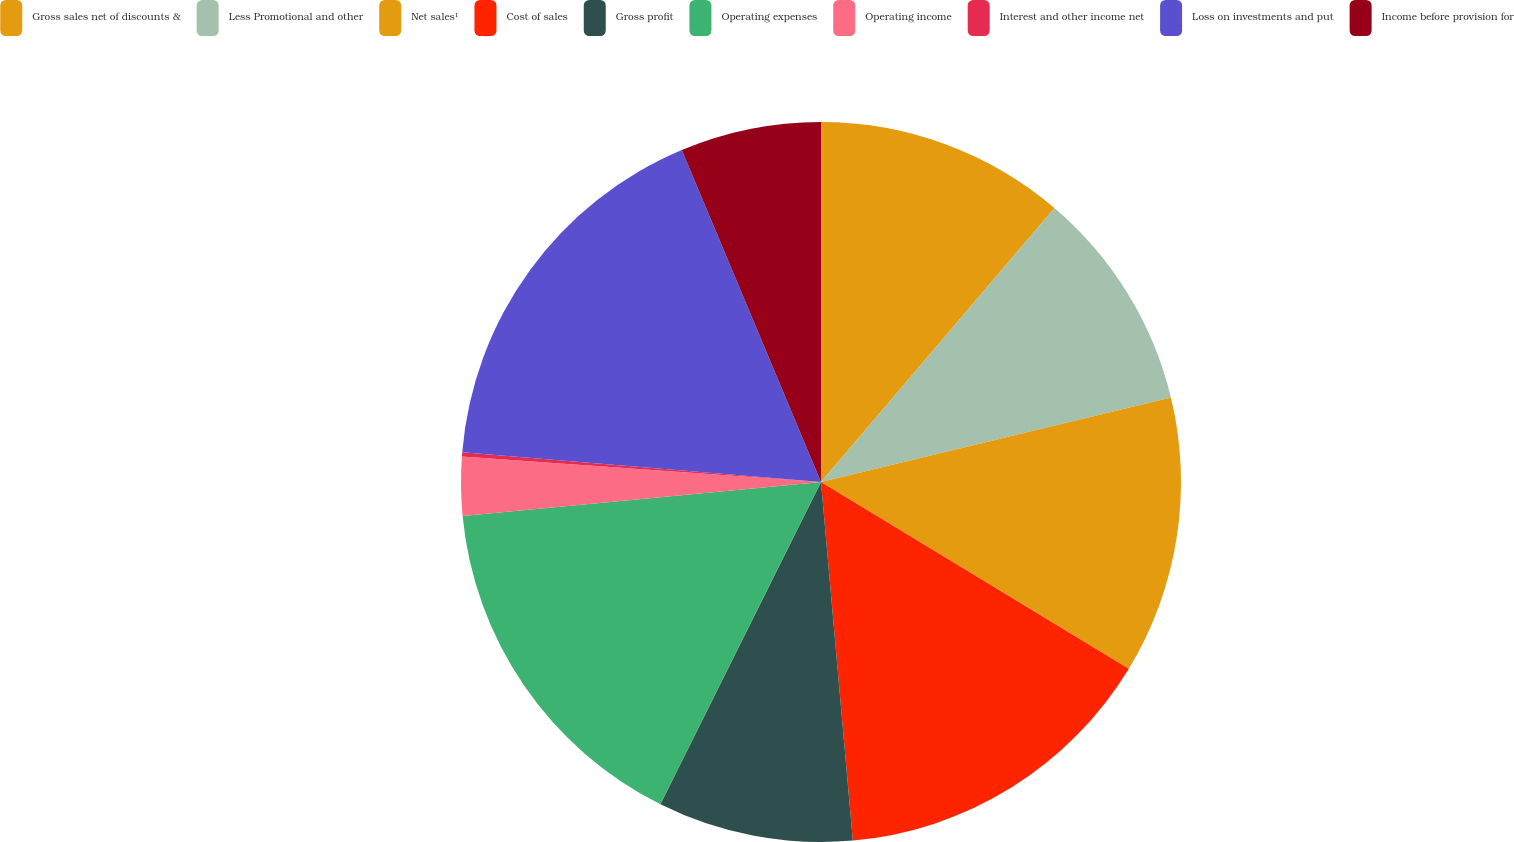<chart> <loc_0><loc_0><loc_500><loc_500><pie_chart><fcel>Gross sales net of discounts &<fcel>Less Promotional and other<fcel>Net sales¹<fcel>Cost of sales<fcel>Gross profit<fcel>Operating expenses<fcel>Operating income<fcel>Interest and other income net<fcel>Loss on investments and put<fcel>Income before provision for<nl><fcel>11.23%<fcel>10.0%<fcel>12.45%<fcel>14.91%<fcel>8.77%<fcel>16.13%<fcel>2.64%<fcel>0.19%<fcel>17.36%<fcel>6.32%<nl></chart> 